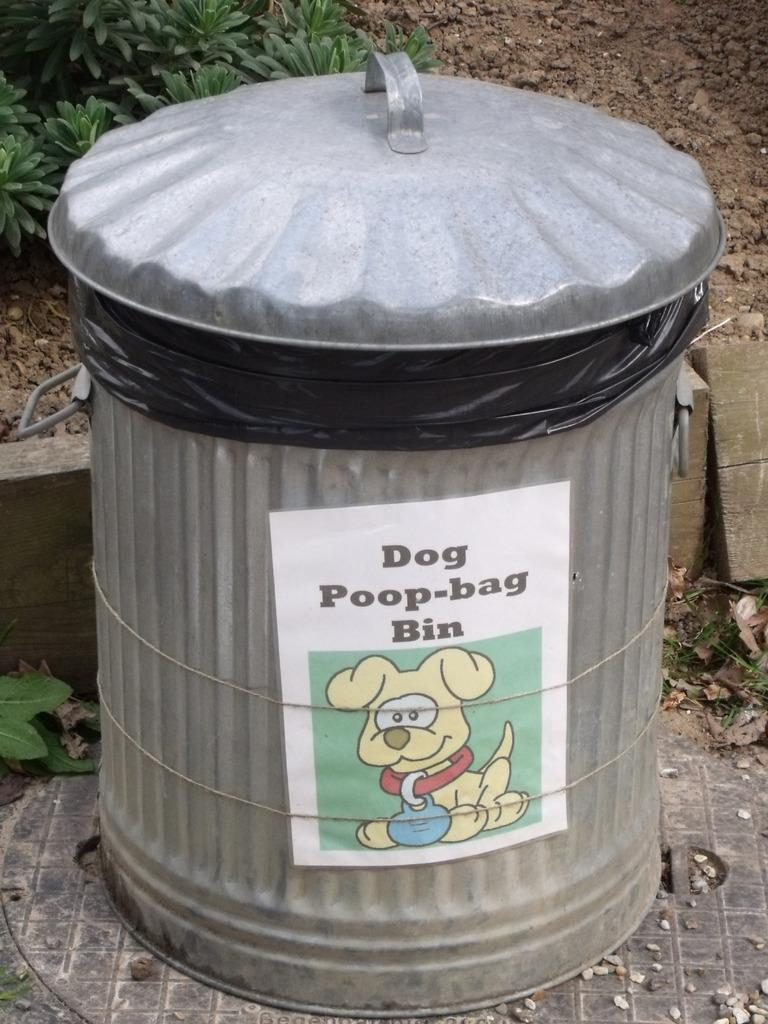What object can be seen on the ground in the image? There is a dustbin in the image, and it is on the ground. What is the color of the dustbin? The dustbin is silver in color. What can be seen in the background of the image? There are plants in the background of the image. What is the color of the plants? The plants are green in color. How much is the payment for the dustbin in the image? There is no payment mentioned or implied in the image, as it is a photograph and not a transaction. 